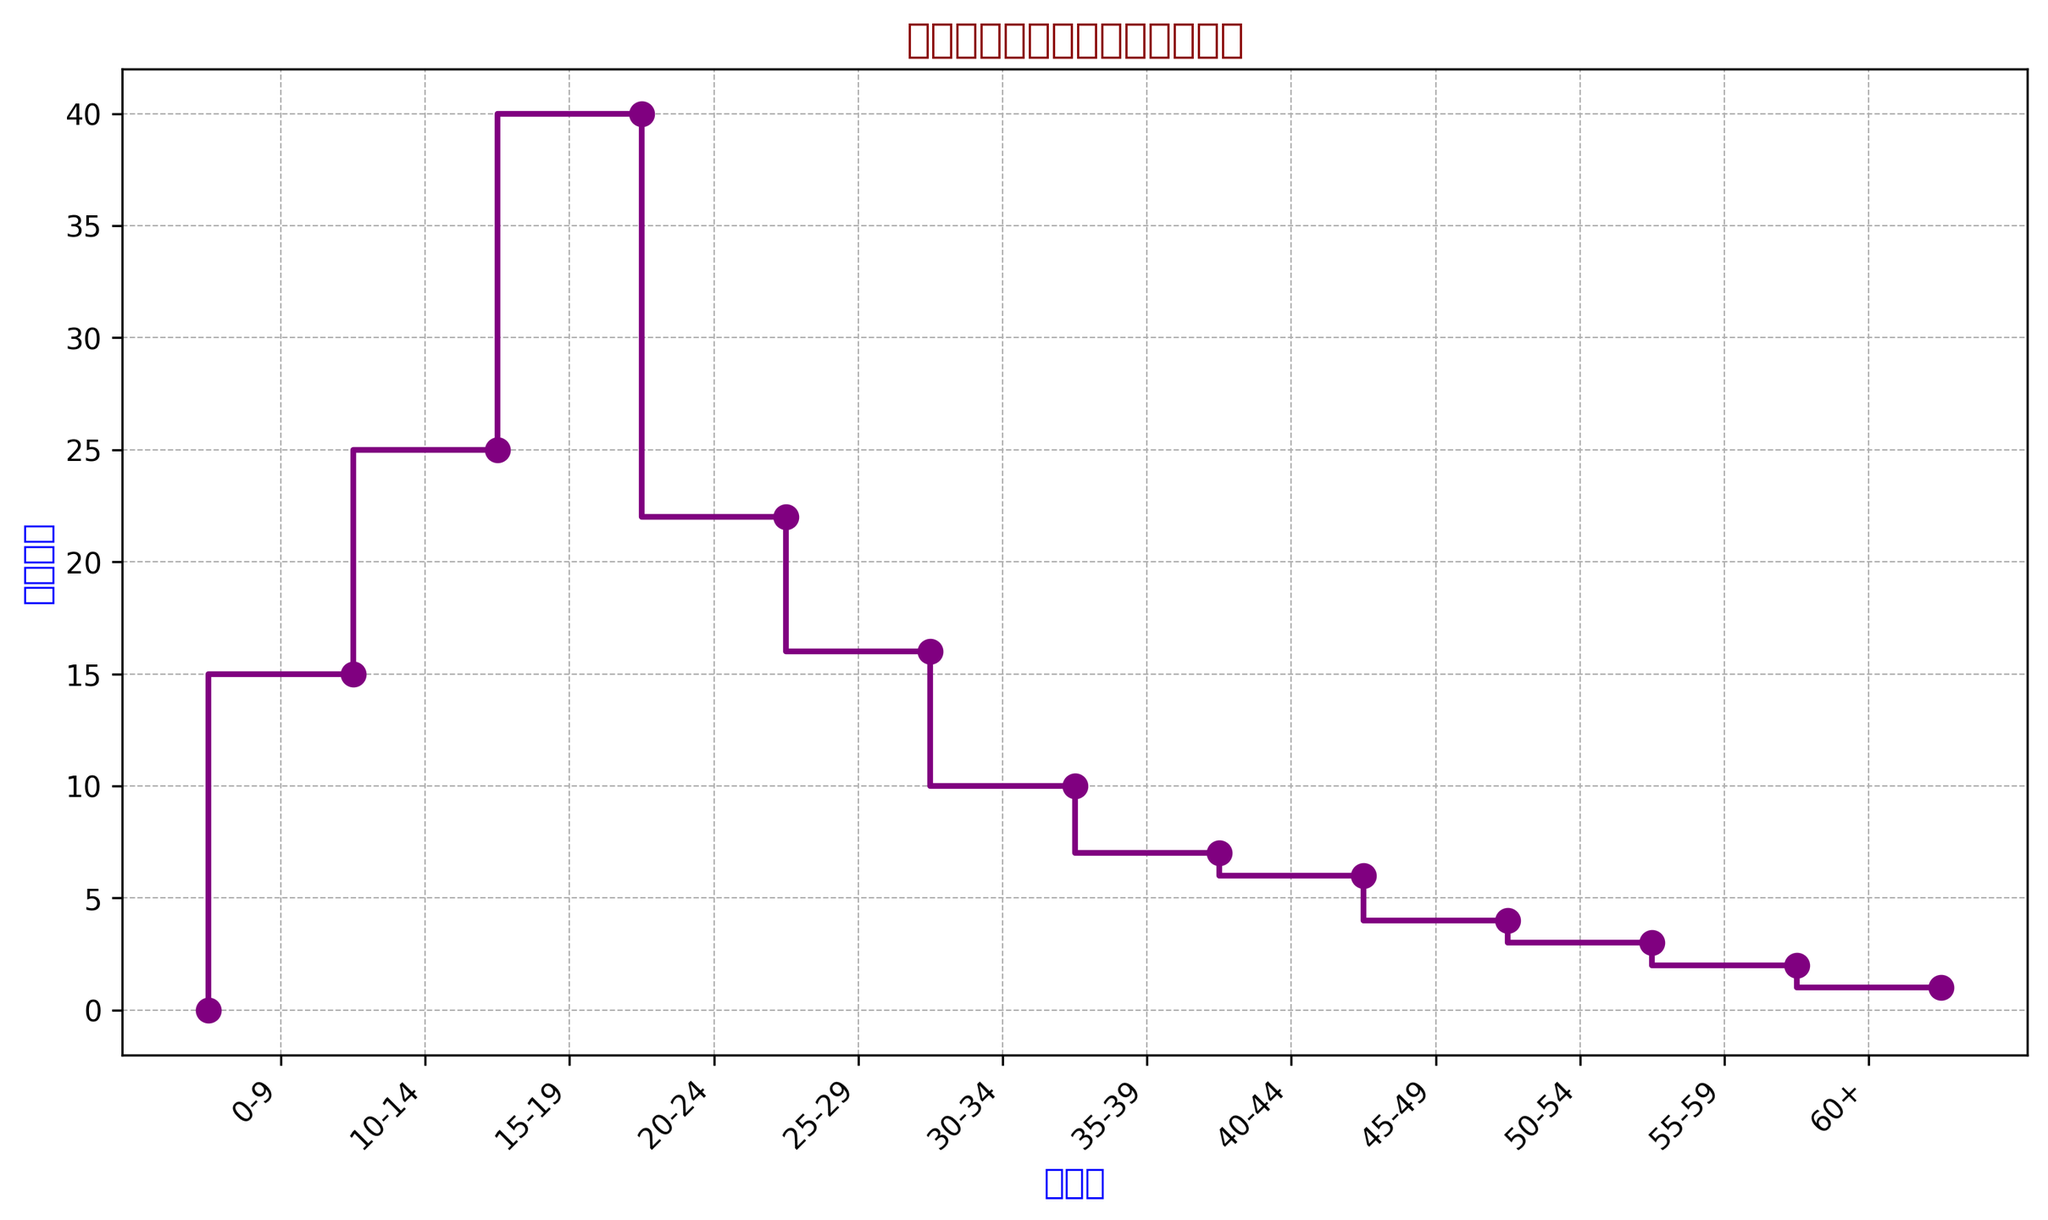哪个年龄段有最多的角色数量？ 根据图表，我们可以看到15-19年龄段的柱状高度最高，说明这段年龄的角色数量最多。
Answer: 15-19 20-24年龄段的角色数量比10-14年龄段多还是少？ 通过观察图表，10-14年龄段的角色数量略高于20-24年龄段。因此20-24年龄段的角色数量较少。
Answer: 少 0-9和60+年龄段的角色数量之和为多少？ 根据图表数据，0-9年龄段有15名角色，60+年龄段有1名角色，二者相加为15 + 1 = 16。
Answer: 16 哪个年龄段的角色数量介于10到15之间？ 从图表中可以看到，25-29、30-34、35-39这几个年龄段的角色数量在10到15之间。
Answer: 25-29, 30-34, 35-39 15-19和20-24年龄段角色数量的均值是多少？ 首先，确定这两个年龄段的角色数量分别是40和22。然后计算平均值：(40 + 22) / 2 = 31。
Answer: 31 哪个年龄段与30-34年龄段的角色数量相等？ 通过观察图表，只有25-29年龄段的角色数量与30-34年龄段相同，都是16。
Answer: 25-29 年龄段0-9到25-29的角色数量总和是多少？ 我们需要将0-9、10-14、15-19、20-24和25-29这几个年龄段的角色数量依次相加：15 + 25 + 40 + 22 + 16 = 118。
Answer: 118 相比35-39年龄段，哪些年龄段的角色数量多于它？ 通过观察图表，我们可以看到角色数量多于35-39年龄段（7个）的有0-9、10-14、15-19、20-24和25-29这几个年龄段。
Answer: 0-9, 10-14, 15-19, 20-24, 25-29 